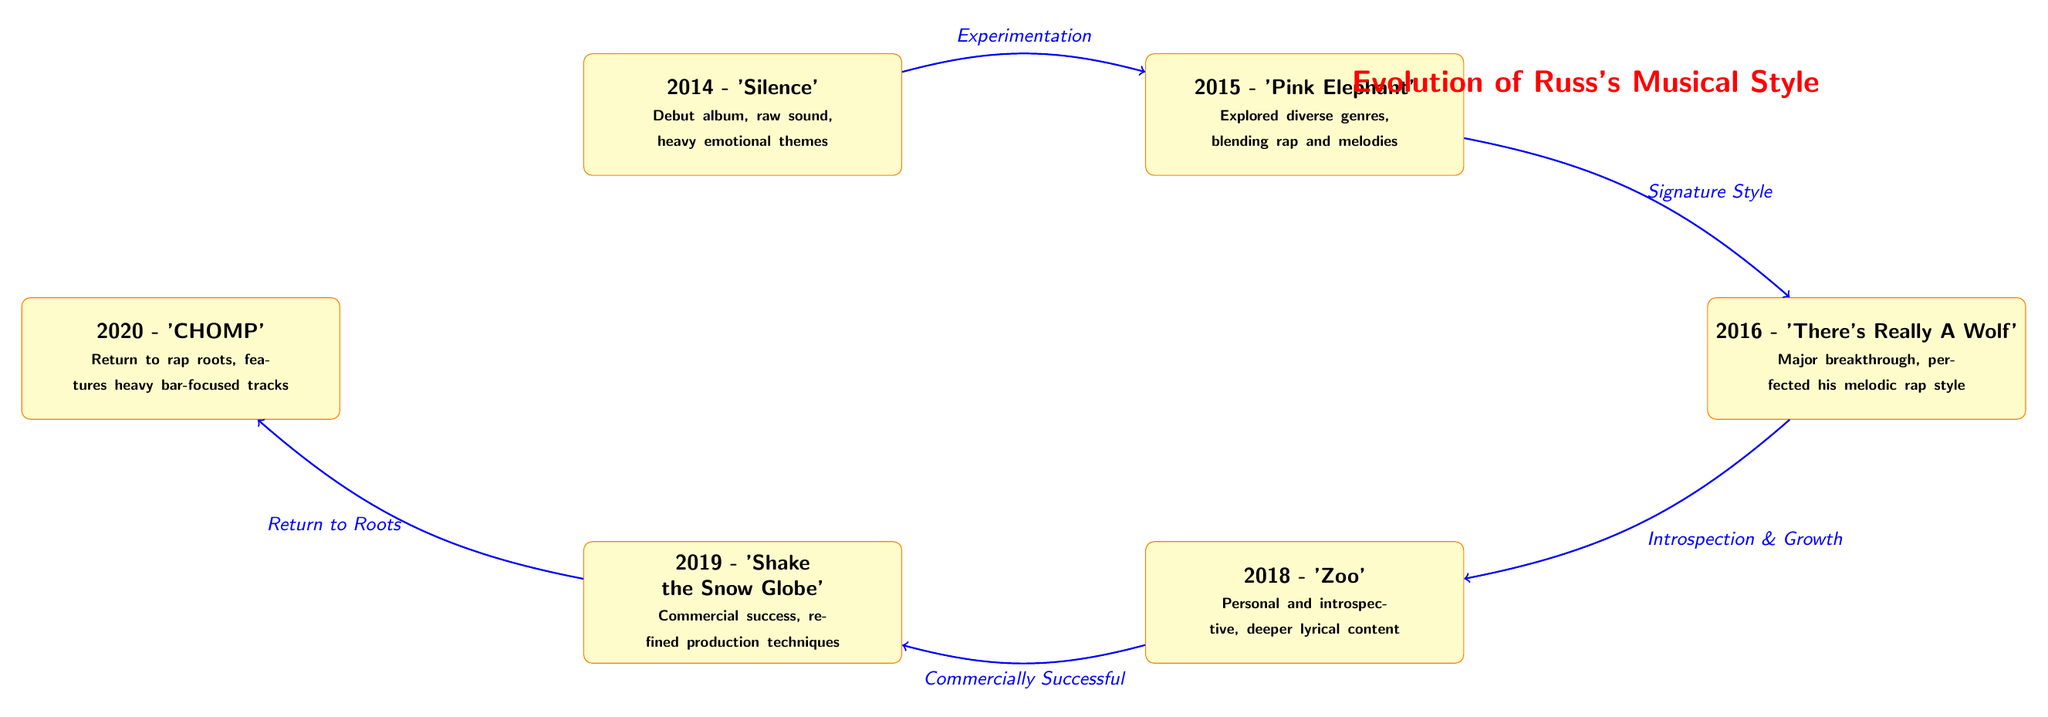What is the title of the diagram? The title of the diagram is found at the top, specifically centered between the albums from 2015 and 2016. It states "Evolution of Russ's Musical Style."
Answer: Evolution of Russ's Musical Style How many albums are featured in the diagram? The diagram shows a total of six albums, listed from 2014 to 2020. Each album is represented by a distinct node.
Answer: 6 What album was released in 2016? By examining the nodes, the album associated with the year 2016 is "There's Really A Wolf," which is specifically listed in that position.
Answer: There's Really A Wolf What transition occurs between 2018 and 2019? The diagram indicates a transition from 2018 ("Zoo") to 2019 ("Shake the Snow Globe") labeled "Commercially Successful," which describes the evolution of the music style during that period.
Answer: Commercially Successful Which album marks Russ's return to rap roots? The node for the year 2020 identifies the album "CHOMP," which is explicitly described as the return to rap roots.
Answer: CHOMP What theme does the 2014 album 'Silence' primarily express? The details within the node for 2014 point out that the album emphasizes "raw sound" and "heavy emotional themes," highlighting its overall thematic approach.
Answer: Heavy emotional themes Which year saw the major breakthrough in Russ's musical style? The diagram shows that 2016, with the release of "There's Really A Wolf," is highlighted as the year of a major breakthrough in his melodic rap style, making it significant in his evolution.
Answer: 2016 What is the transition described between 2016 and 2018? The arrow connecting the nodes from 2016 to 2018 indicates the transition labeled "Introspection & Growth," denoting a shift in lyrical depth over those years.
Answer: Introspection & Growth What are the characteristics of the album released in 2019? The node for the album "Shake the Snow Globe" in 2019 is characterized by "refined production techniques" and further emphasizes its commercial success, as noted in the explanatory text.
Answer: Refined production techniques 